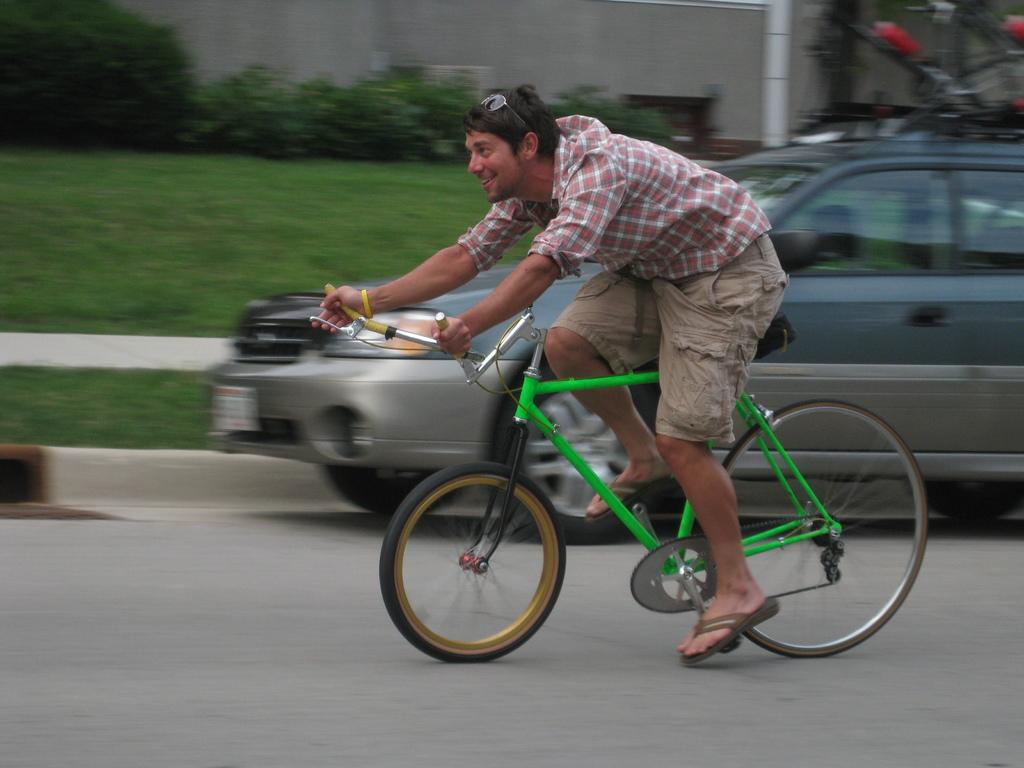What is the person in the image doing? The person is riding a bicycle in the image. What color is the bicycle? The bicycle is green. Where is the person riding the bicycle? The person is on the road. What is behind the person while riding the bicycle? There is a car behind the person. What type of vegetation can be seen in the image? There is grass visible in the image, and there are also trees. What type of stretch is the person doing while riding the bicycle in the image? The person is not doing any stretches while riding the bicycle in the image; they are simply riding the bicycle. What event is taking place in the image? There is no specific event taking place in the image; it is simply a person riding a bicycle on the road. 